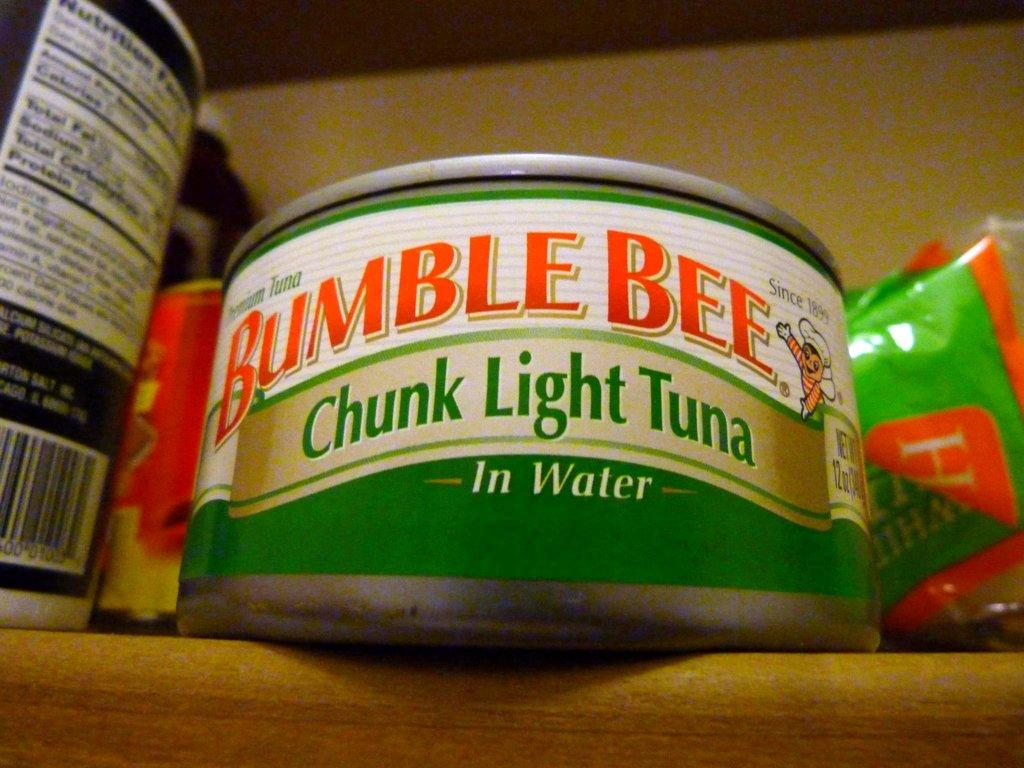<image>
Write a terse but informative summary of the picture. a can of bumble bee chunk light tuna in water 